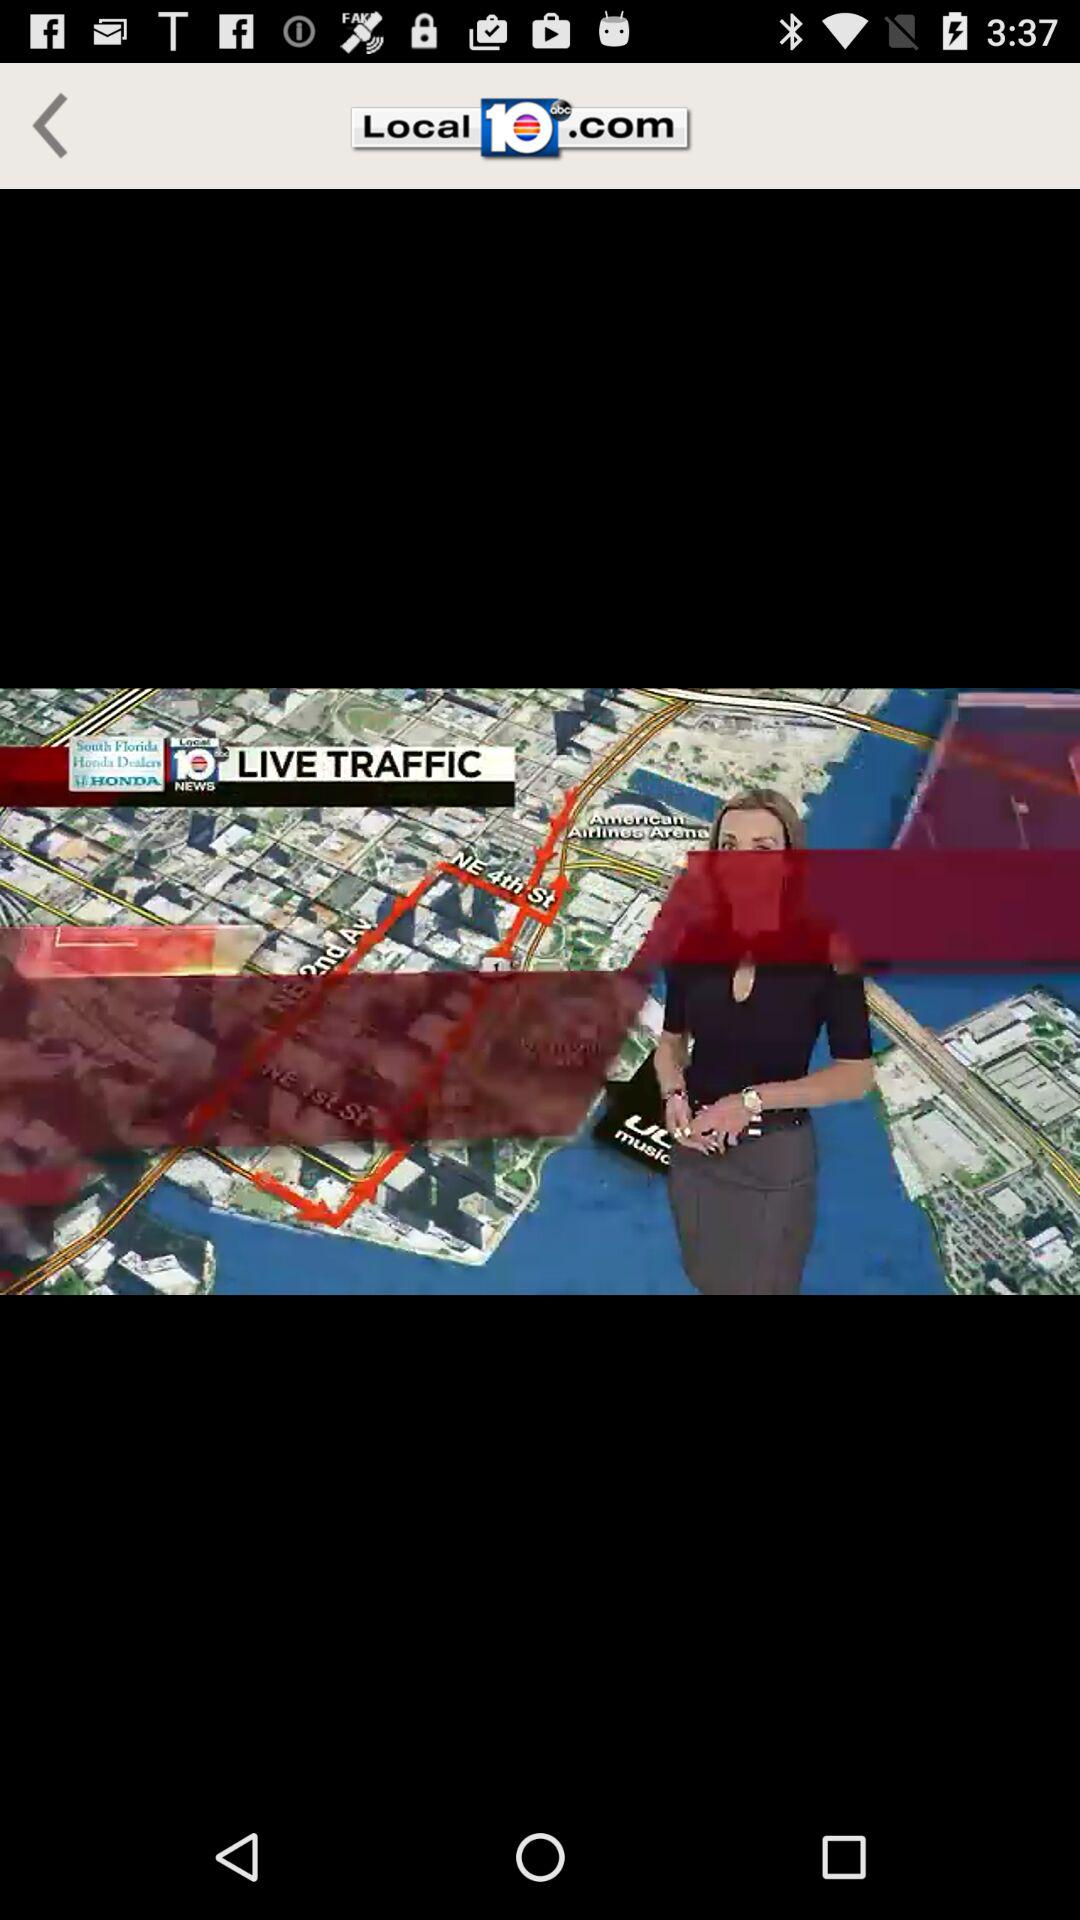What is the application name? The application name is "Local 10". 